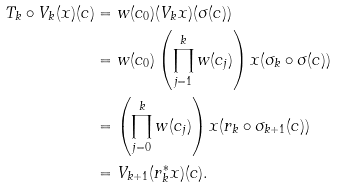Convert formula to latex. <formula><loc_0><loc_0><loc_500><loc_500>T _ { k } \circ V _ { k } ( x ) ( c ) & = w ( c _ { 0 } ) ( V _ { k } x ) ( \sigma ( c ) ) \\ & = w ( c _ { 0 } ) \left ( \prod _ { j = 1 } ^ { k } w ( c _ { j } ) \right ) x ( \sigma _ { k } \circ \sigma ( c ) ) \\ & = \left ( \prod _ { j = 0 } ^ { k } w ( c _ { j } ) \right ) x ( r _ { k } \circ \sigma _ { k + 1 } ( c ) ) \\ & = V _ { k + 1 } ( r _ { k } ^ { * } x ) ( c ) .</formula> 